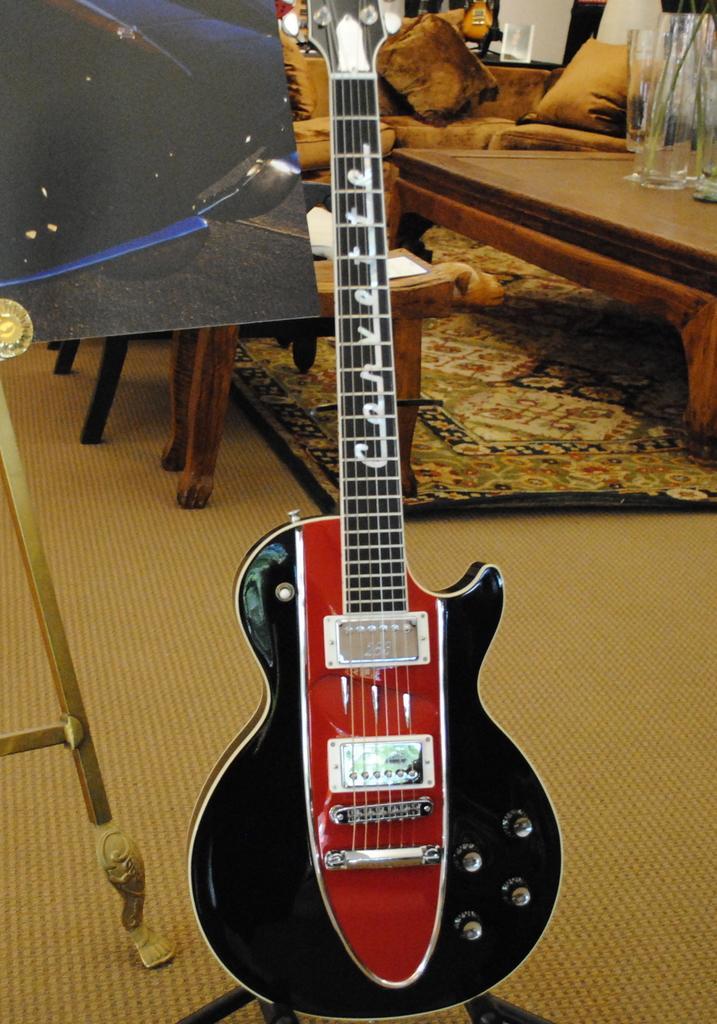Can you describe this image briefly? This image is taken inside a room. In the middle of the image there is a guitar which is in black color. At the bottom of the image there is a floor with mat. In the right side of the image there is a coffee table, on top of it there is a bottle. In the background there is a board with painting on it and few chairs and a sofa with pillows on it. 